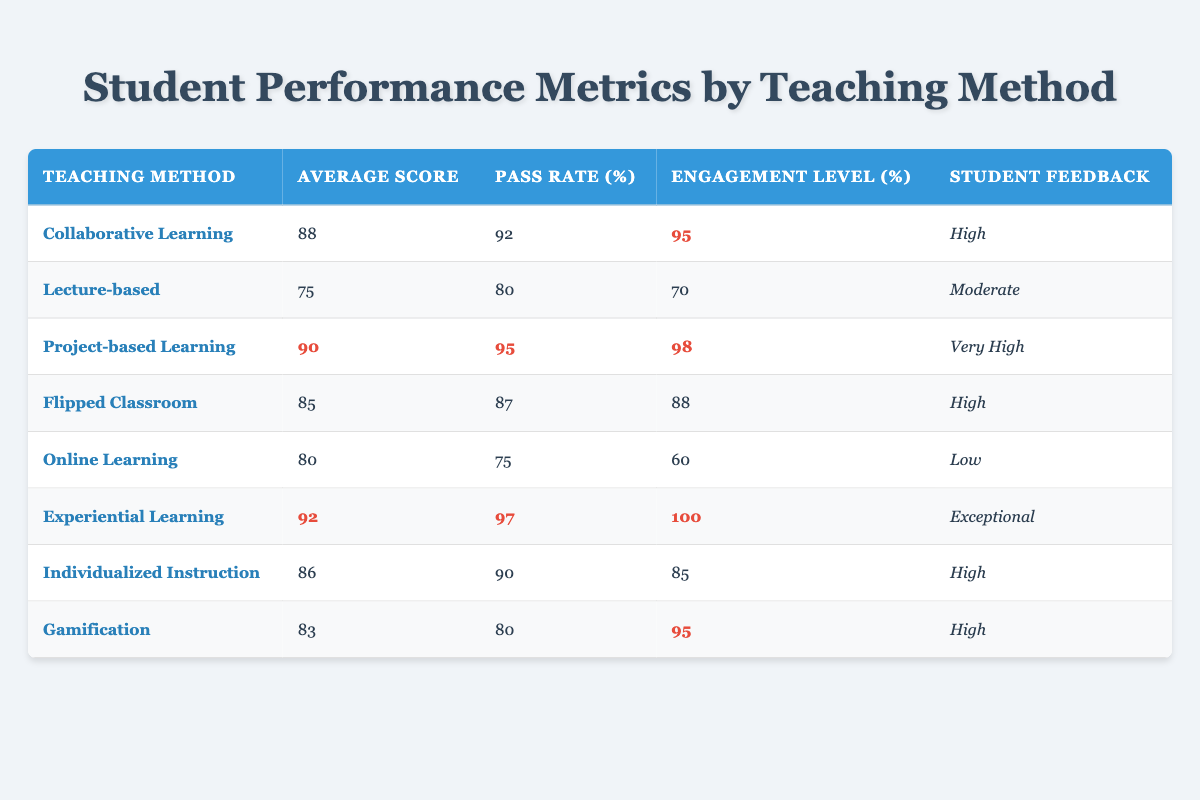What's the teaching method with the highest average score? The highest average score in the table is associated with "Experiential Learning," which has an average score of 92.
Answer: Experiential Learning What is the pass rate for Project-based Learning? The pass rate for "Project-based Learning" is highlighted in the table as 95%.
Answer: 95% Which teaching methods have a pass rate of over 90%? By checking each method's pass rate, we find that "Collaborative Learning" (92%), "Project-based Learning" (95%), and "Experiential Learning" (97%) all exceed 90%.
Answer: Collaborative Learning, Project-based Learning, Experiential Learning What is the engagement level for Online Learning? The engagement level for "Online Learning" is listed as 60%.
Answer: 60% Which teaching method shows the lowest student feedback? According to the table, "Online Learning" has the lowest student feedback, rated as "Low."
Answer: Online Learning How much higher is the engagement level of Experiential Learning compared to the Lecture-based method? The engagement level for "Experiential Learning" is 100%, while for "Lecture-based," it is 70%. The difference is calculated as 100% - 70% = 30%.
Answer: 30% Is the average score for Individualized Instruction greater than that for Flipped Classroom? The average score for "Individualized Instruction" is 86, and for "Flipped Classroom," it is 85. Since 86 > 85, the statement is true.
Answer: Yes What is the average engagement level among the teaching methods listed? To find the average engagement, we add the engagement levels (95 + 70 + 98 + 88 + 60 + 100 + 85 + 95 = 689) and divide by the number of methods (8). The average is 689/8 = 86.125.
Answer: 86.125 Which teaching method has both the highest average score and highest engagement level? The method "Experiential Learning" has both the highest average score (92) and the highest engagement level (100).
Answer: Experiential Learning What is the difference between the average scores of Collaborative Learning and Gamification? The average score for "Collaborative Learning" is 88, and for "Gamification," it is 83. The difference is 88 - 83 = 5.
Answer: 5 